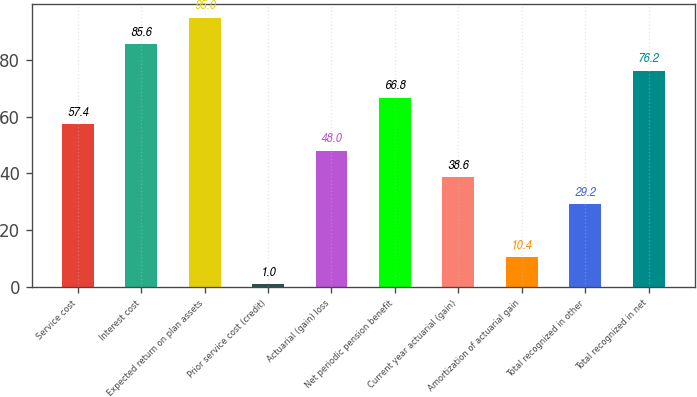Convert chart. <chart><loc_0><loc_0><loc_500><loc_500><bar_chart><fcel>Service cost<fcel>Interest cost<fcel>Expected return on plan assets<fcel>Prior service cost (credit)<fcel>Actuarial (gain) loss<fcel>Net periodic pension benefit<fcel>Current year actuarial (gain)<fcel>Amortization of actuarial gain<fcel>Total recognized in other<fcel>Total recognized in net<nl><fcel>57.4<fcel>85.6<fcel>95<fcel>1<fcel>48<fcel>66.8<fcel>38.6<fcel>10.4<fcel>29.2<fcel>76.2<nl></chart> 